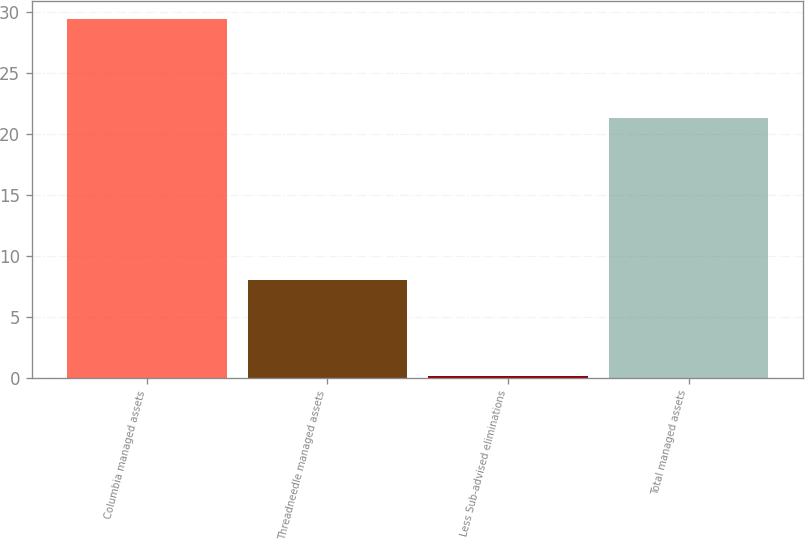Convert chart to OTSL. <chart><loc_0><loc_0><loc_500><loc_500><bar_chart><fcel>Columbia managed assets<fcel>Threadneedle managed assets<fcel>Less Sub-advised eliminations<fcel>Total managed assets<nl><fcel>29.4<fcel>8<fcel>0.1<fcel>21.3<nl></chart> 